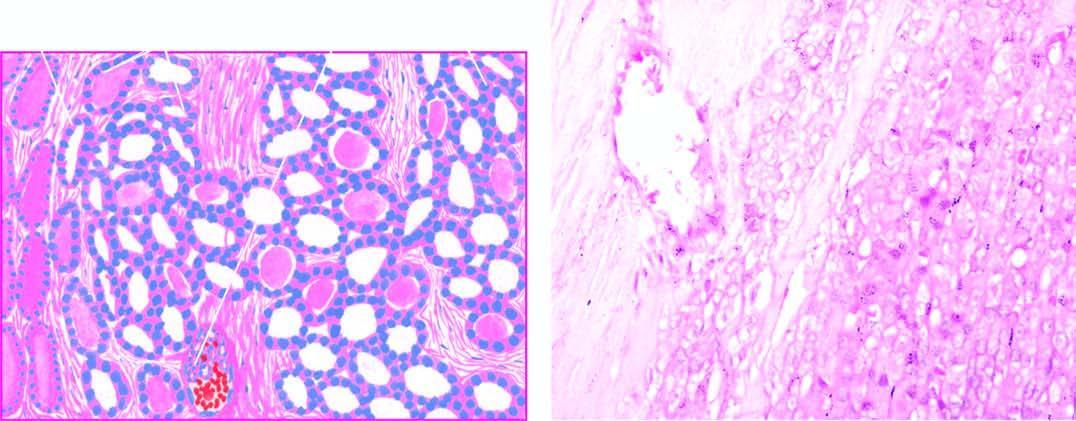what are the follicles lined by?
Answer the question using a single word or phrase. Tumour cells 